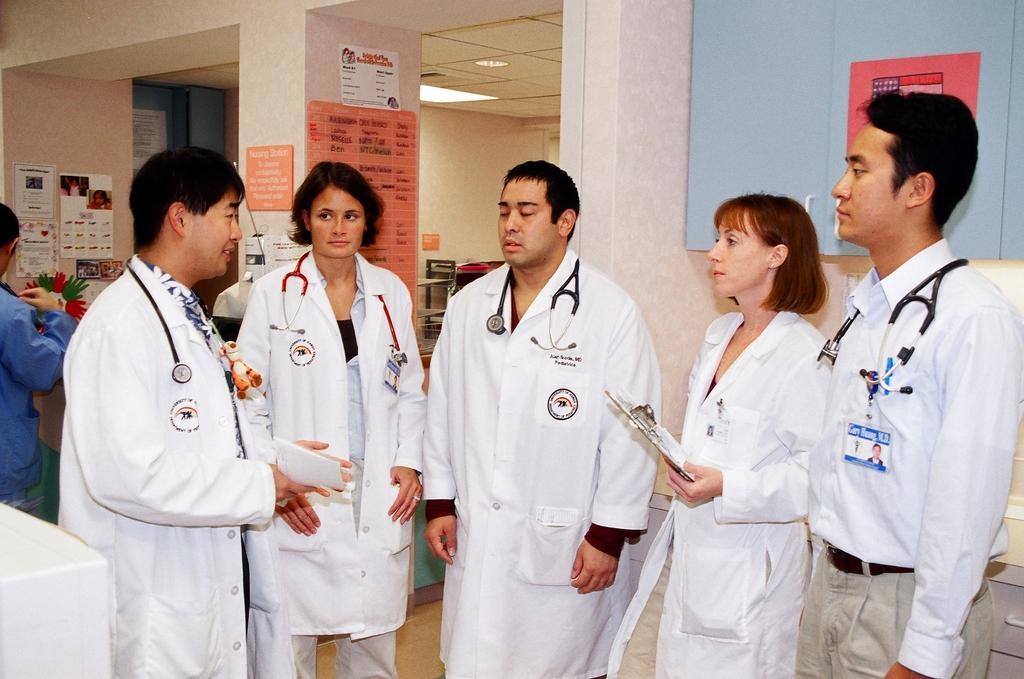Please provide a concise description of this image. In this image, we can see people standing. We can see a woman and man are holding some objects. In the background, we can see walls, posters, table, shelves, pillar, ceiling, light and some objects. In the bottom left corner, there is a white object. 